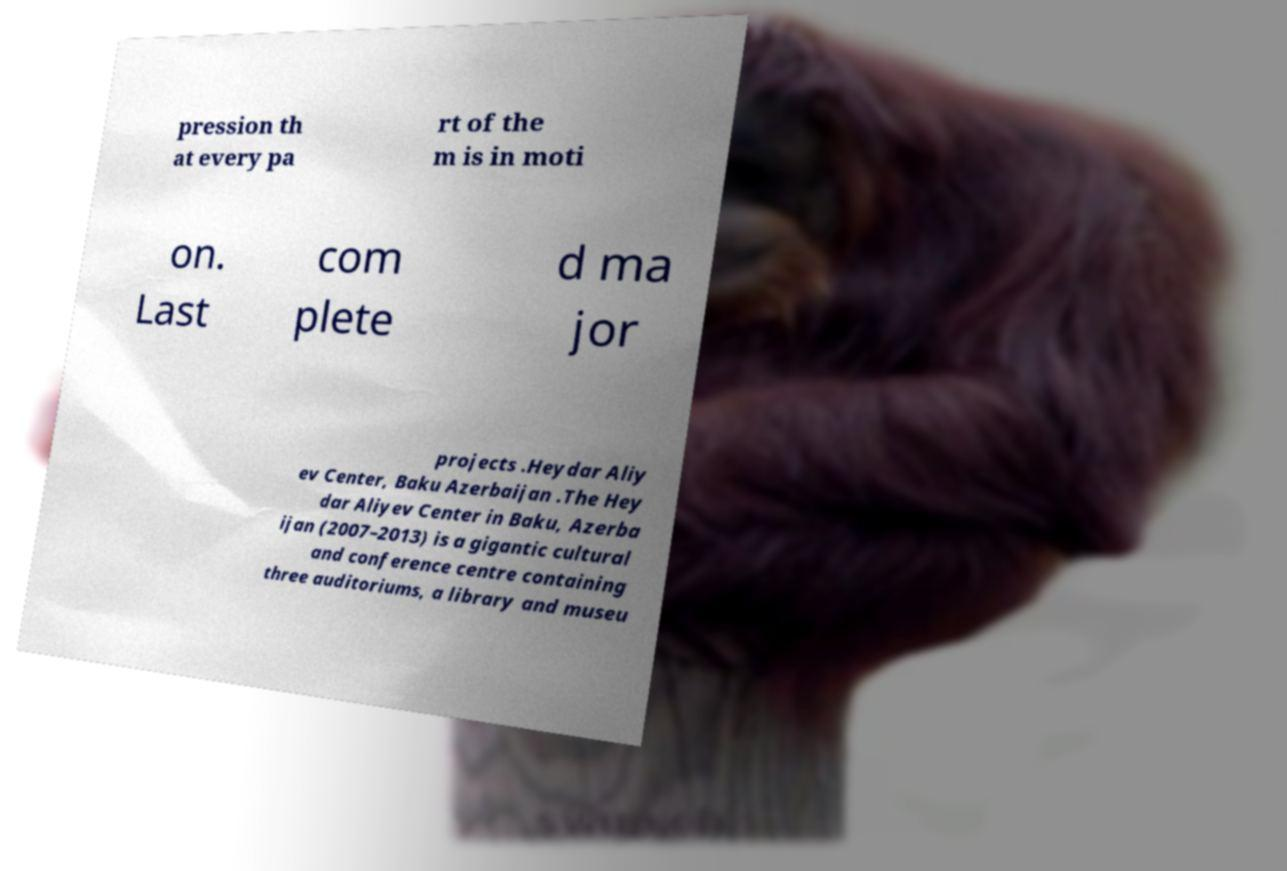Please identify and transcribe the text found in this image. pression th at every pa rt of the m is in moti on. Last com plete d ma jor projects .Heydar Aliy ev Center, Baku Azerbaijan .The Hey dar Aliyev Center in Baku, Azerba ijan (2007–2013) is a gigantic cultural and conference centre containing three auditoriums, a library and museu 